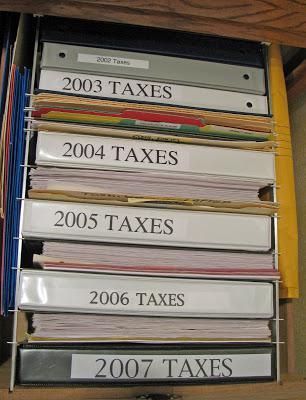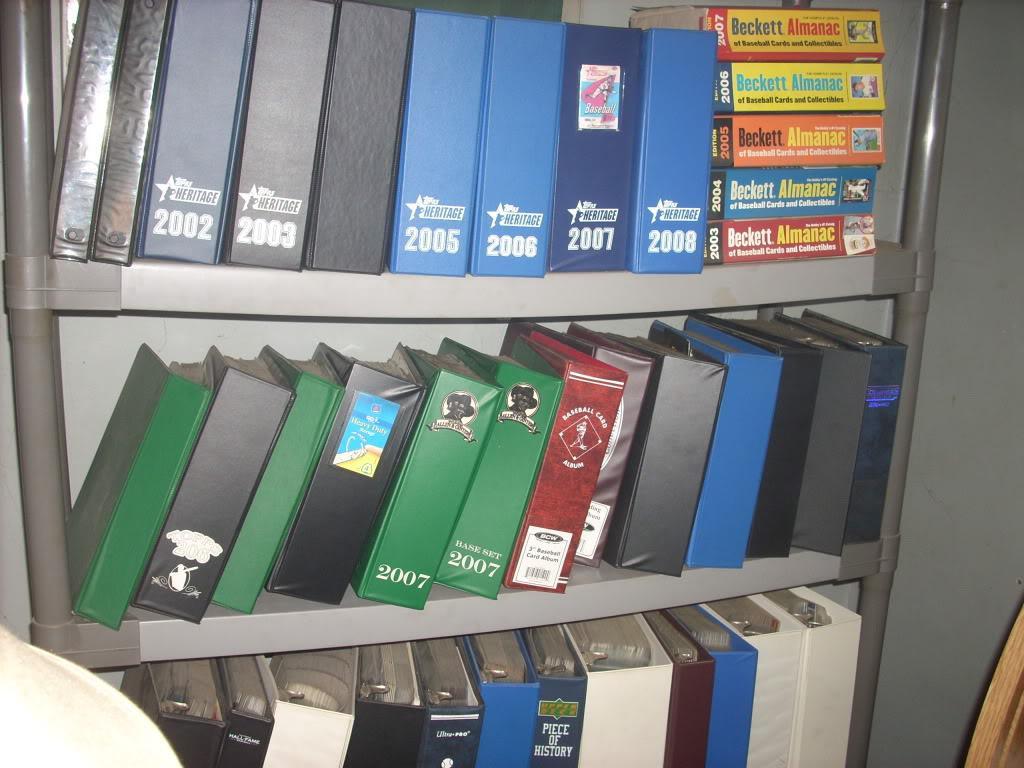The first image is the image on the left, the second image is the image on the right. For the images shown, is this caption "One image shows binders of various colors arranged vertically on tiered shelves." true? Answer yes or no. Yes. 